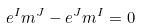<formula> <loc_0><loc_0><loc_500><loc_500>e ^ { I } _ { \L } m ^ { J \L } - e ^ { J } _ { \L } m ^ { I \L } = 0</formula> 